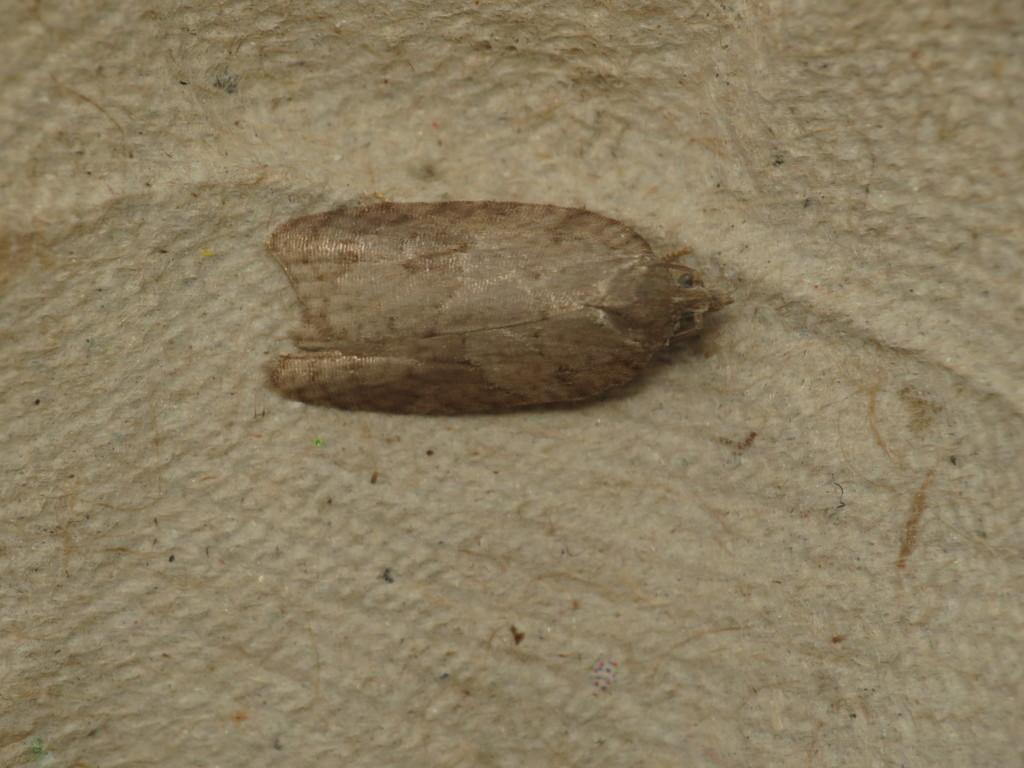What type of creature is present in the image? There is an insect in the image. What is the insect situated on in the image? The insect is on a brown surface. What type of balls are being used in the protest depicted in the image? There is no protest or balls present in the image; it features an insect on a brown surface. What is the condition of the wrist of the person holding the insect in the image? There is no person or wrist present in the image; it features an insect on a brown surface. 